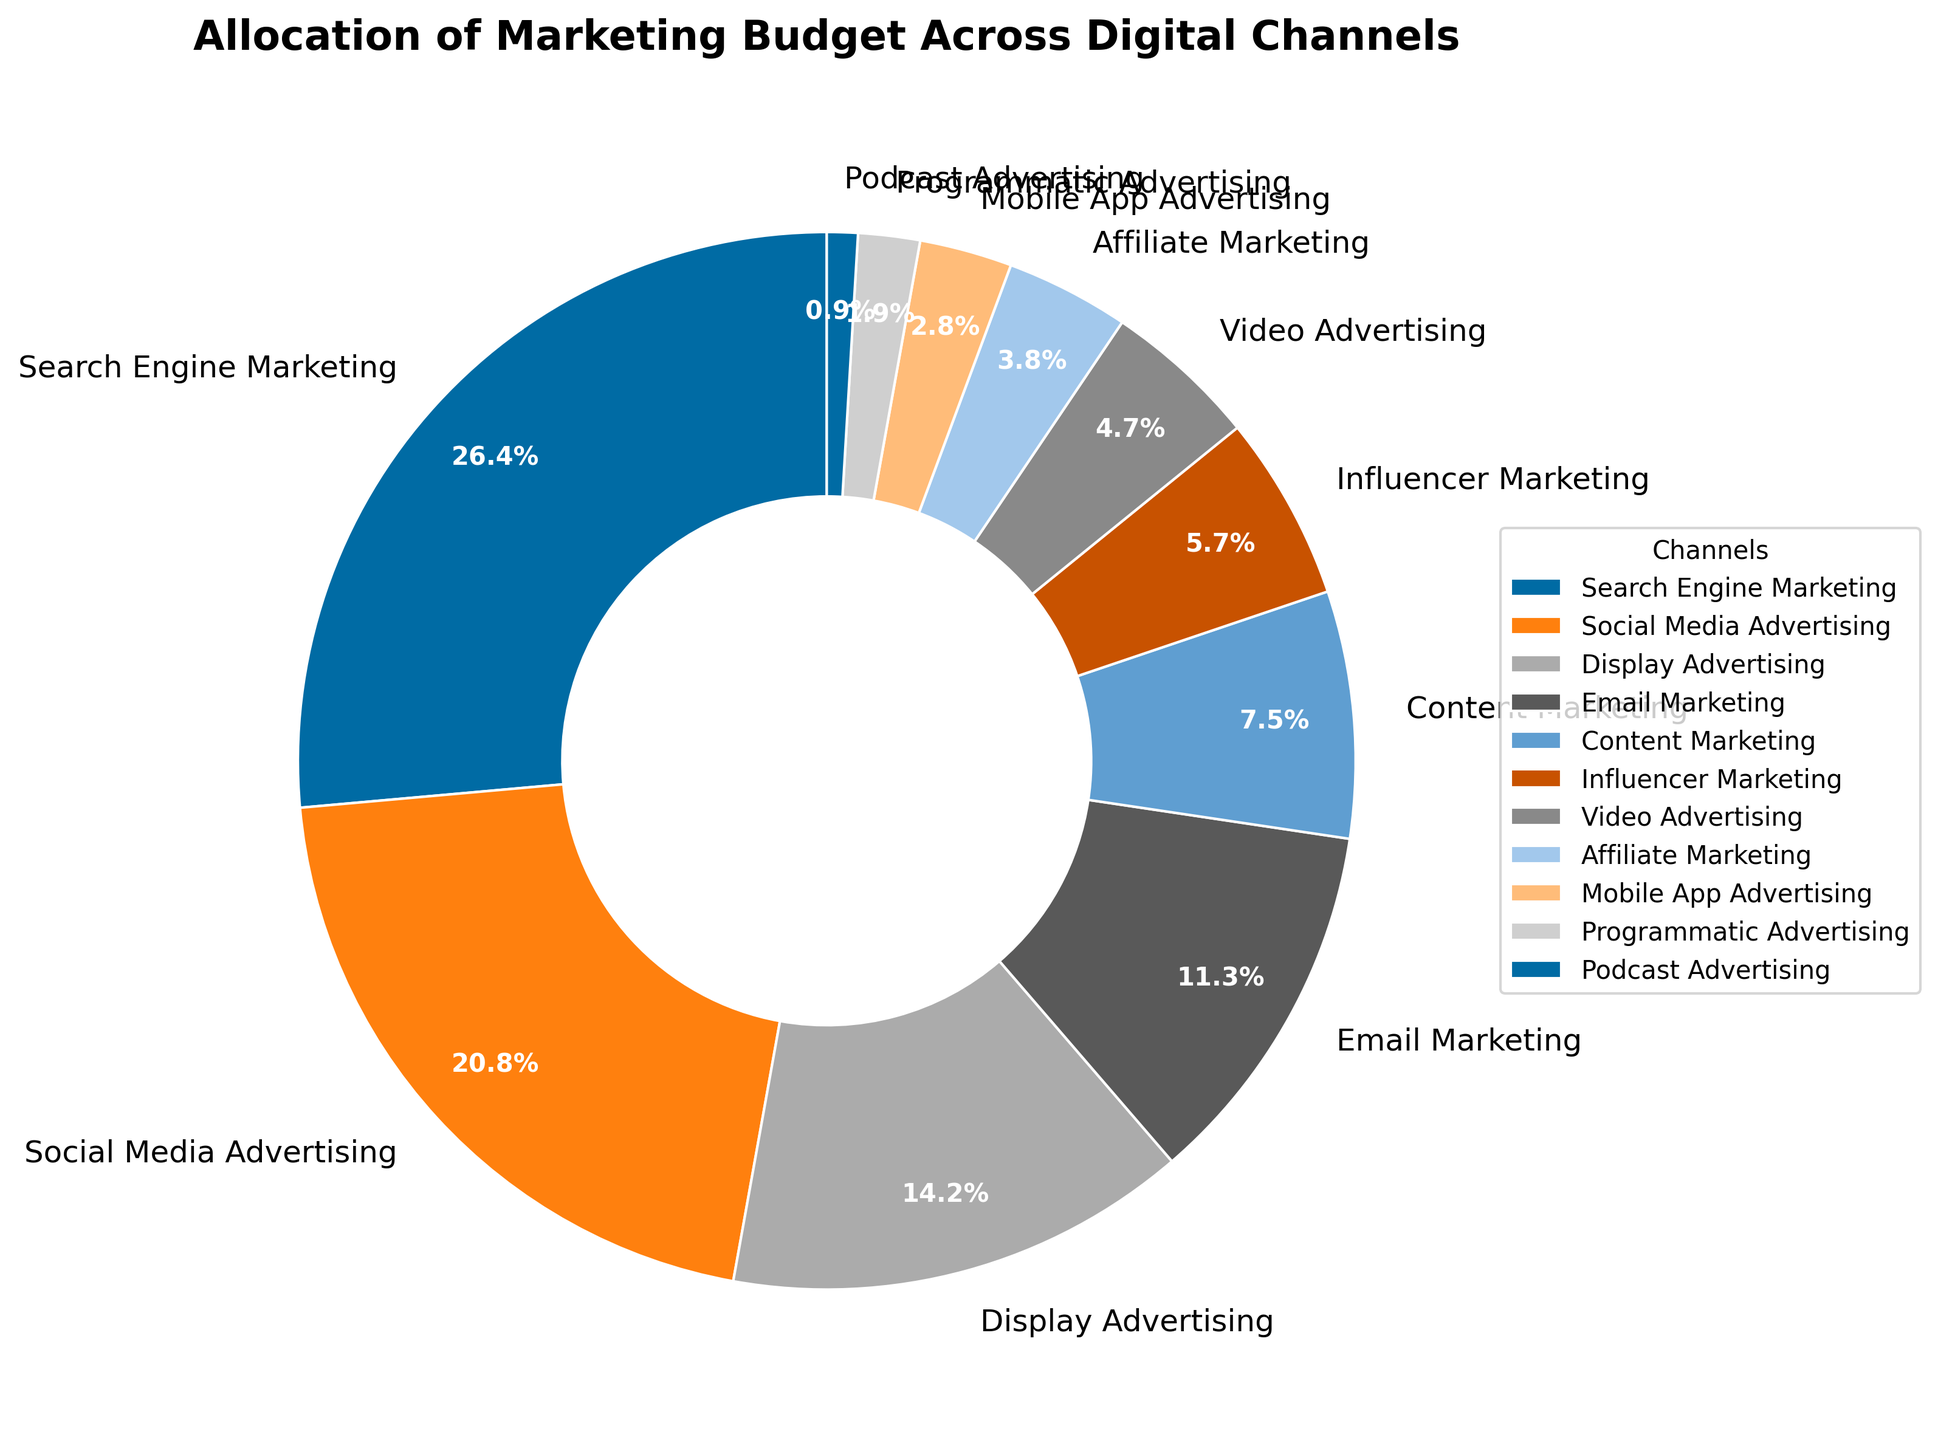What percentage of the marketing budget is allocated to Search Engine Marketing? The slice representing Search Engine Marketing shows it accounts for 28% of the total marketing budget.
Answer: 28% Which digital channel has the smallest allocation of the marketing budget? The smallest slice in the pie chart corresponds to Podcast Advertising, which has a very small section relative to others.
Answer: Podcast Advertising What is the combined percentage allocation for Content Marketing and Influencer Marketing? Content Marketing has 8% and Influencer Marketing has 6%, adding these together gives: 8% + 6% = 14%.
Answer: 14% Which channel has a higher budget allocation: Video Advertising or Mobile App Advertising? By comparing the slices, it's seen that Video Advertising has a 5% allocation while Mobile App Advertising has 3%.
Answer: Video Advertising How much more allocation does Social Media Advertising have compared to Display Advertising? Social Media Advertising has 22% and Display Advertising has 15%. The difference is: 22% - 15% = 7%.
Answer: 7% What is the total percentage allocation for channels with a single-digit percentage? Summing the percentages for Content Marketing (8%), Influencer Marketing (6%), Video Advertising (5%), Affiliate Marketing (4%), Mobile App Advertising (3%), Programmatic Advertising (2%), and Podcast Advertising (1%): 8% + 6% + 5% + 4% + 3% + 2% + 1% = 29%.
Answer: 29% Is Email Marketing allocated more of the budget than Display Advertising? Comparing the sizes of the slices, Display Advertising has a higher allocation of 15%, whereas Email Marketing has 12%.
Answer: No List all digital channels that receive at least 10% of the marketing budget. The slices that are equal to or greater than 10% include Search Engine Marketing (28%), Social Media Advertising (22%), and Display Advertising (15%).
Answer: Search Engine Marketing, Social Media Advertising, Display Advertising What is the average percentage allocation of the top three highest allocated channels? The top three highest allocations are: Search Engine Marketing (28%), Social Media Advertising (22%), and Display Advertising (15%). The average is (28% + 22% + 15%) / 3 = (65%) / 3 ≈ 21.67%.
Answer: 21.67% Which sector has a percentage allocation closest to the average allocation of all sectors combined? The total percentage is 100%, and with 11 sectors, the average allocation is 100% / 11 ≈ 9.09%. Content Marketing with 8% is the closest to this average.
Answer: Content Marketing 